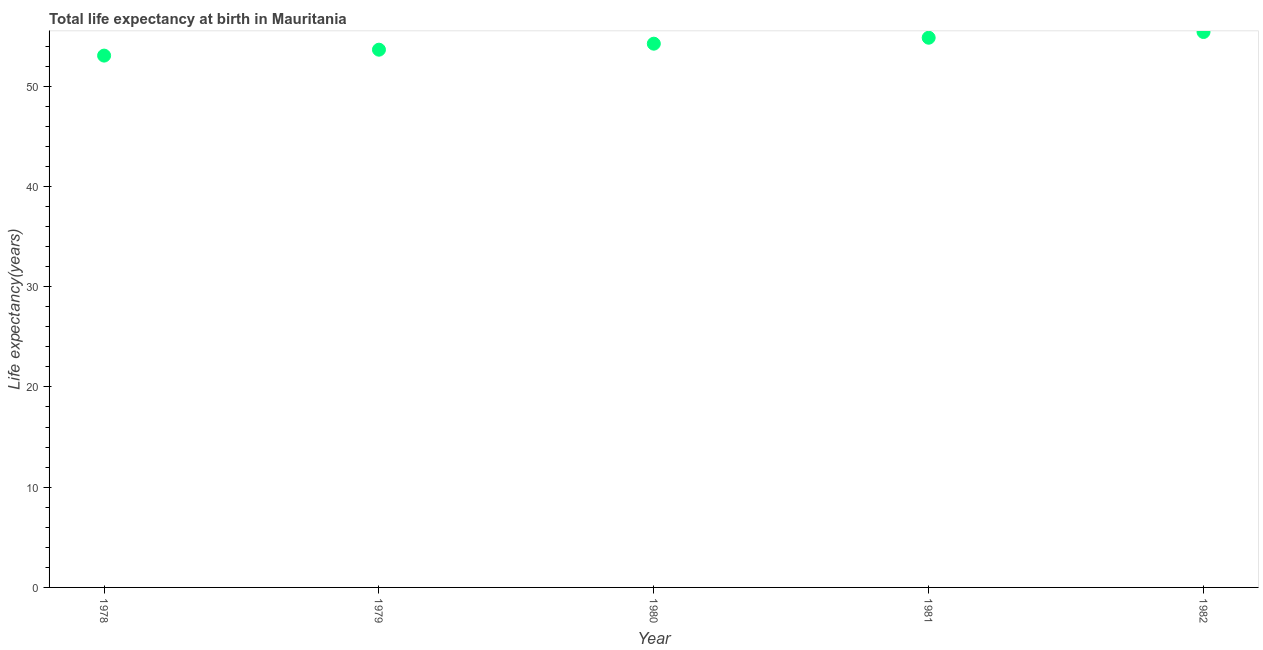What is the life expectancy at birth in 1980?
Give a very brief answer. 54.24. Across all years, what is the maximum life expectancy at birth?
Give a very brief answer. 55.41. Across all years, what is the minimum life expectancy at birth?
Offer a very short reply. 53.05. In which year was the life expectancy at birth maximum?
Your answer should be very brief. 1982. In which year was the life expectancy at birth minimum?
Your answer should be very brief. 1978. What is the sum of the life expectancy at birth?
Ensure brevity in your answer.  271.18. What is the difference between the life expectancy at birth in 1979 and 1982?
Give a very brief answer. -1.76. What is the average life expectancy at birth per year?
Keep it short and to the point. 54.24. What is the median life expectancy at birth?
Keep it short and to the point. 54.24. What is the ratio of the life expectancy at birth in 1979 to that in 1980?
Keep it short and to the point. 0.99. What is the difference between the highest and the second highest life expectancy at birth?
Offer a very short reply. 0.57. What is the difference between the highest and the lowest life expectancy at birth?
Offer a very short reply. 2.35. In how many years, is the life expectancy at birth greater than the average life expectancy at birth taken over all years?
Your answer should be compact. 3. Does the life expectancy at birth monotonically increase over the years?
Your response must be concise. Yes. How many dotlines are there?
Provide a short and direct response. 1. How many years are there in the graph?
Ensure brevity in your answer.  5. What is the difference between two consecutive major ticks on the Y-axis?
Keep it short and to the point. 10. Does the graph contain any zero values?
Provide a succinct answer. No. What is the title of the graph?
Provide a succinct answer. Total life expectancy at birth in Mauritania. What is the label or title of the Y-axis?
Provide a short and direct response. Life expectancy(years). What is the Life expectancy(years) in 1978?
Your response must be concise. 53.05. What is the Life expectancy(years) in 1979?
Your response must be concise. 53.64. What is the Life expectancy(years) in 1980?
Provide a short and direct response. 54.24. What is the Life expectancy(years) in 1981?
Provide a short and direct response. 54.84. What is the Life expectancy(years) in 1982?
Offer a terse response. 55.41. What is the difference between the Life expectancy(years) in 1978 and 1979?
Make the answer very short. -0.59. What is the difference between the Life expectancy(years) in 1978 and 1980?
Give a very brief answer. -1.19. What is the difference between the Life expectancy(years) in 1978 and 1981?
Your response must be concise. -1.78. What is the difference between the Life expectancy(years) in 1978 and 1982?
Offer a terse response. -2.35. What is the difference between the Life expectancy(years) in 1979 and 1980?
Offer a very short reply. -0.6. What is the difference between the Life expectancy(years) in 1979 and 1981?
Ensure brevity in your answer.  -1.19. What is the difference between the Life expectancy(years) in 1979 and 1982?
Keep it short and to the point. -1.76. What is the difference between the Life expectancy(years) in 1980 and 1981?
Make the answer very short. -0.59. What is the difference between the Life expectancy(years) in 1980 and 1982?
Make the answer very short. -1.16. What is the difference between the Life expectancy(years) in 1981 and 1982?
Make the answer very short. -0.57. What is the ratio of the Life expectancy(years) in 1978 to that in 1979?
Your response must be concise. 0.99. What is the ratio of the Life expectancy(years) in 1978 to that in 1982?
Offer a very short reply. 0.96. What is the ratio of the Life expectancy(years) in 1979 to that in 1982?
Your answer should be very brief. 0.97. What is the ratio of the Life expectancy(years) in 1980 to that in 1982?
Offer a terse response. 0.98. What is the ratio of the Life expectancy(years) in 1981 to that in 1982?
Provide a succinct answer. 0.99. 